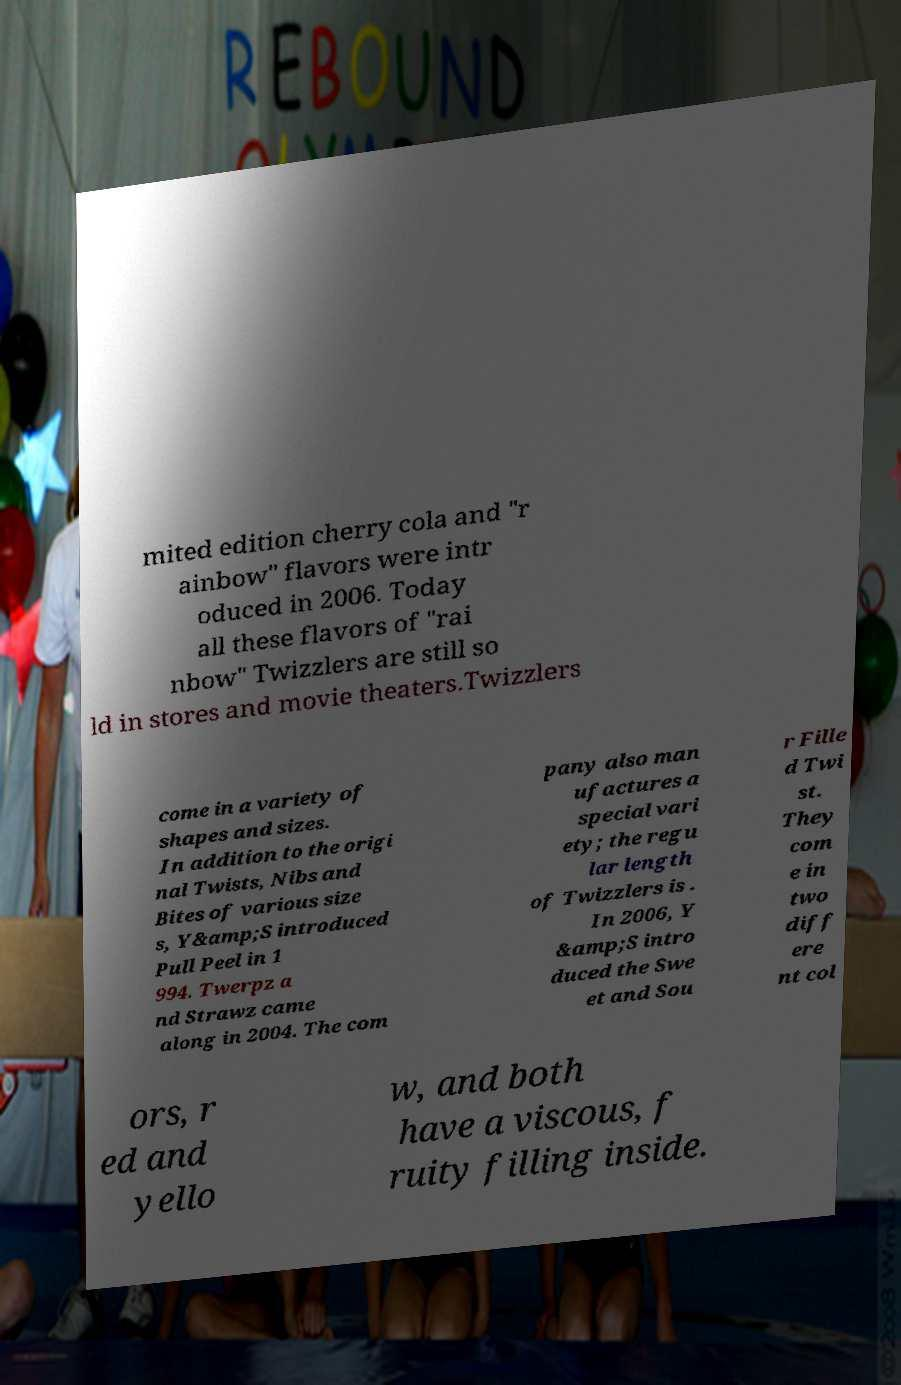There's text embedded in this image that I need extracted. Can you transcribe it verbatim? mited edition cherry cola and "r ainbow" flavors were intr oduced in 2006. Today all these flavors of "rai nbow" Twizzlers are still so ld in stores and movie theaters.Twizzlers come in a variety of shapes and sizes. In addition to the origi nal Twists, Nibs and Bites of various size s, Y&amp;S introduced Pull Peel in 1 994. Twerpz a nd Strawz came along in 2004. The com pany also man ufactures a special vari ety; the regu lar length of Twizzlers is . In 2006, Y &amp;S intro duced the Swe et and Sou r Fille d Twi st. They com e in two diff ere nt col ors, r ed and yello w, and both have a viscous, f ruity filling inside. 